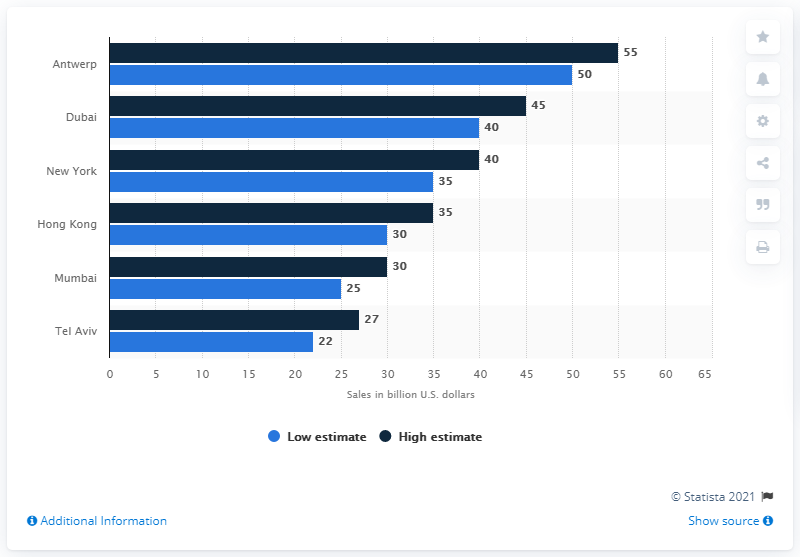Outline some significant characteristics in this image. Antwerp generated approximately $50 million in revenue from diamond sales in the United States in 2012. 